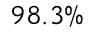Convert formula to latex. <formula><loc_0><loc_0><loc_500><loc_500>9 8 . 3 \%</formula> 